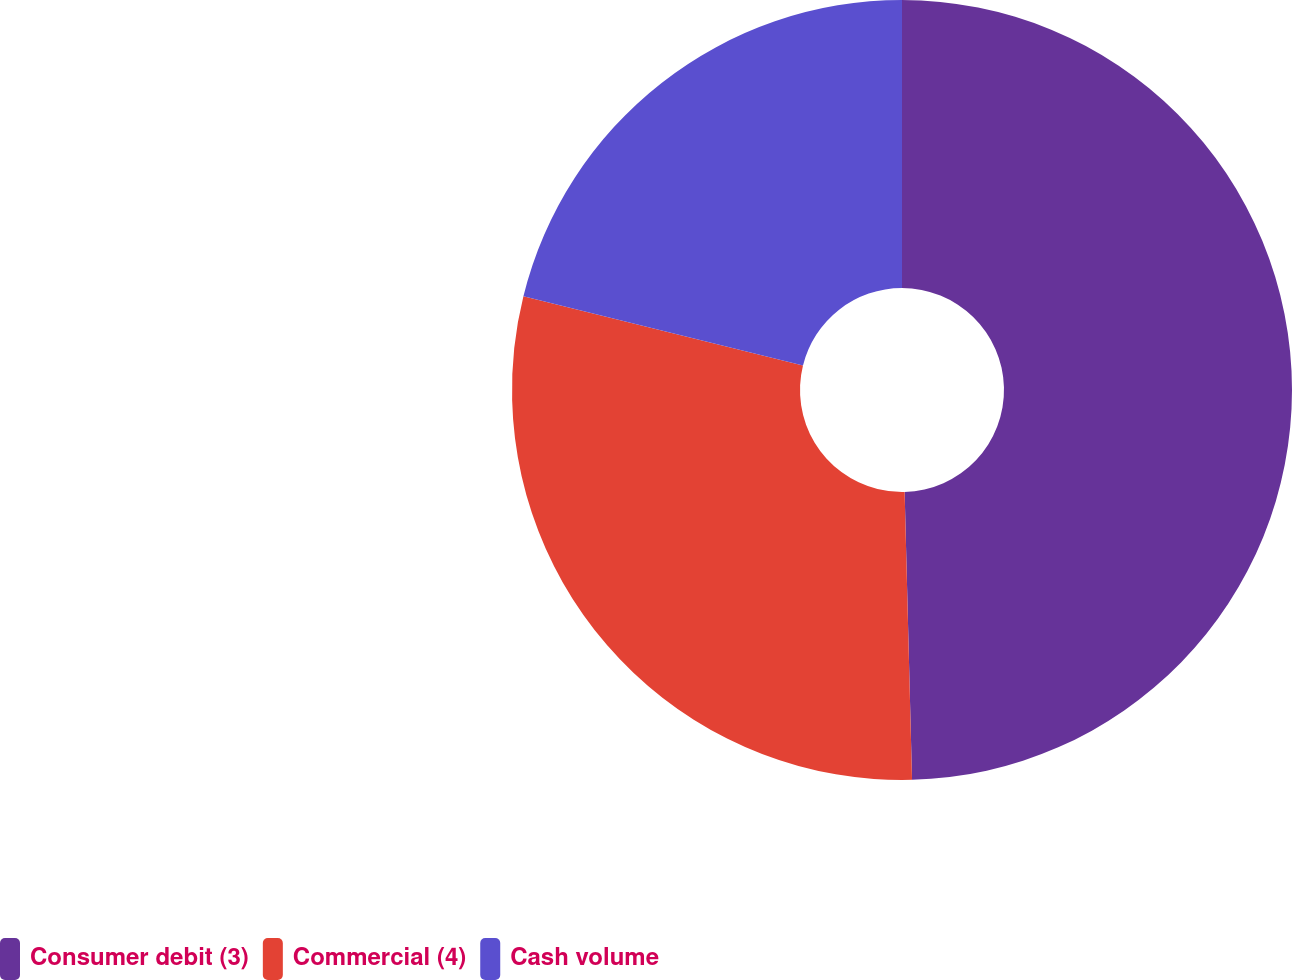<chart> <loc_0><loc_0><loc_500><loc_500><pie_chart><fcel>Consumer debit (3)<fcel>Commercial (4)<fcel>Cash volume<nl><fcel>49.59%<fcel>29.27%<fcel>21.14%<nl></chart> 